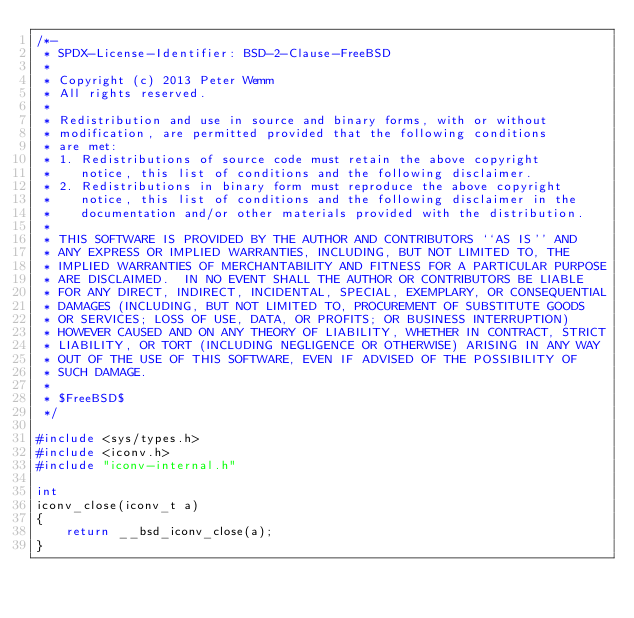Convert code to text. <code><loc_0><loc_0><loc_500><loc_500><_C_>/*-
 * SPDX-License-Identifier: BSD-2-Clause-FreeBSD
 *
 * Copyright (c) 2013 Peter Wemm
 * All rights reserved.
 *
 * Redistribution and use in source and binary forms, with or without
 * modification, are permitted provided that the following conditions
 * are met:
 * 1. Redistributions of source code must retain the above copyright
 *    notice, this list of conditions and the following disclaimer.
 * 2. Redistributions in binary form must reproduce the above copyright
 *    notice, this list of conditions and the following disclaimer in the
 *    documentation and/or other materials provided with the distribution.
 *
 * THIS SOFTWARE IS PROVIDED BY THE AUTHOR AND CONTRIBUTORS ``AS IS'' AND
 * ANY EXPRESS OR IMPLIED WARRANTIES, INCLUDING, BUT NOT LIMITED TO, THE
 * IMPLIED WARRANTIES OF MERCHANTABILITY AND FITNESS FOR A PARTICULAR PURPOSE
 * ARE DISCLAIMED.  IN NO EVENT SHALL THE AUTHOR OR CONTRIBUTORS BE LIABLE
 * FOR ANY DIRECT, INDIRECT, INCIDENTAL, SPECIAL, EXEMPLARY, OR CONSEQUENTIAL
 * DAMAGES (INCLUDING, BUT NOT LIMITED TO, PROCUREMENT OF SUBSTITUTE GOODS
 * OR SERVICES; LOSS OF USE, DATA, OR PROFITS; OR BUSINESS INTERRUPTION)
 * HOWEVER CAUSED AND ON ANY THEORY OF LIABILITY, WHETHER IN CONTRACT, STRICT
 * LIABILITY, OR TORT (INCLUDING NEGLIGENCE OR OTHERWISE) ARISING IN ANY WAY
 * OUT OF THE USE OF THIS SOFTWARE, EVEN IF ADVISED OF THE POSSIBILITY OF
 * SUCH DAMAGE.
 *
 * $FreeBSD$
 */

#include <sys/types.h>
#include <iconv.h>
#include "iconv-internal.h"

int
iconv_close(iconv_t a)
{
	return __bsd_iconv_close(a);
}
</code> 